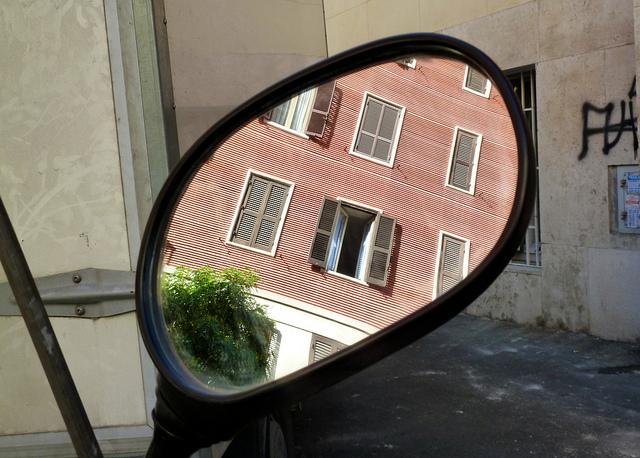How many windows are open?
Be succinct. 2. What is growing on the house?
Answer briefly. Moss. Is this a side mirror?
Keep it brief. Yes. Is there a person in the window?
Write a very short answer. No. 